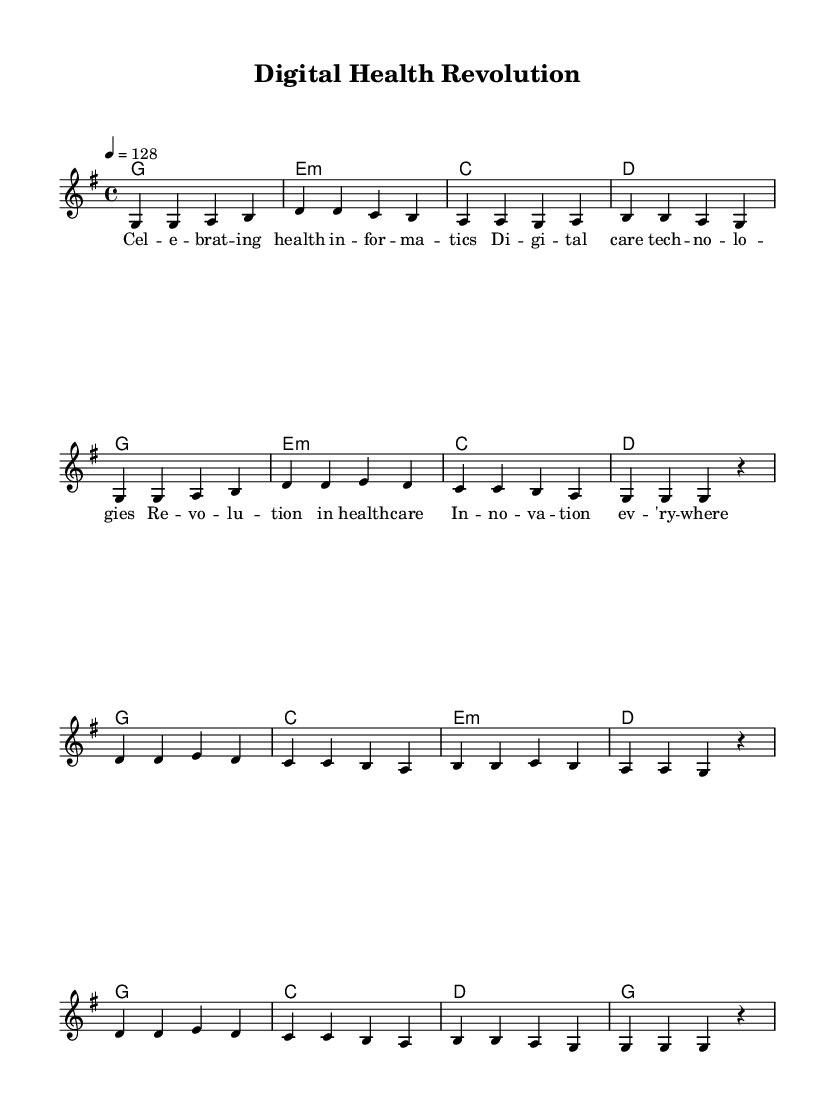What is the key signature of this music? The key signature is G major, as indicated by the presence of one sharp (F#) at the beginning of the score.
Answer: G major What is the time signature of this music? The time signature is 4/4, as shown at the beginning of the score, which indicates four beats per measure with a quarter note receiving one beat.
Answer: 4/4 What is the tempo marking indicated in the music? The tempo marking is 128, stated in the code as "4 = 128", which means that there are 128 beats per minute.
Answer: 128 How many measures are in the verse section? The verse consists of 8 measures, which can be counted from the melody section where each new line signifies a measure.
Answer: 8 What section follows the verse in this music? The chorus follows the verse, as indicated by the structure of the melody and the lyric placement in the sheet music.
Answer: Chorus Which technological advancements are celebrated in the lyrics? The lyrics celebrate "digital care technologies," referring to advancements in health informatics and technology's role in healthcare.
Answer: Digital care technologies What is the rhythmic pattern primarily used in this upbeat K-pop track? The rhythmic pattern predominantly consists of quarter notes and eighth notes, creating an energetic and danceable feel typical of K-pop genres.
Answer: Quarter notes and eighth notes 